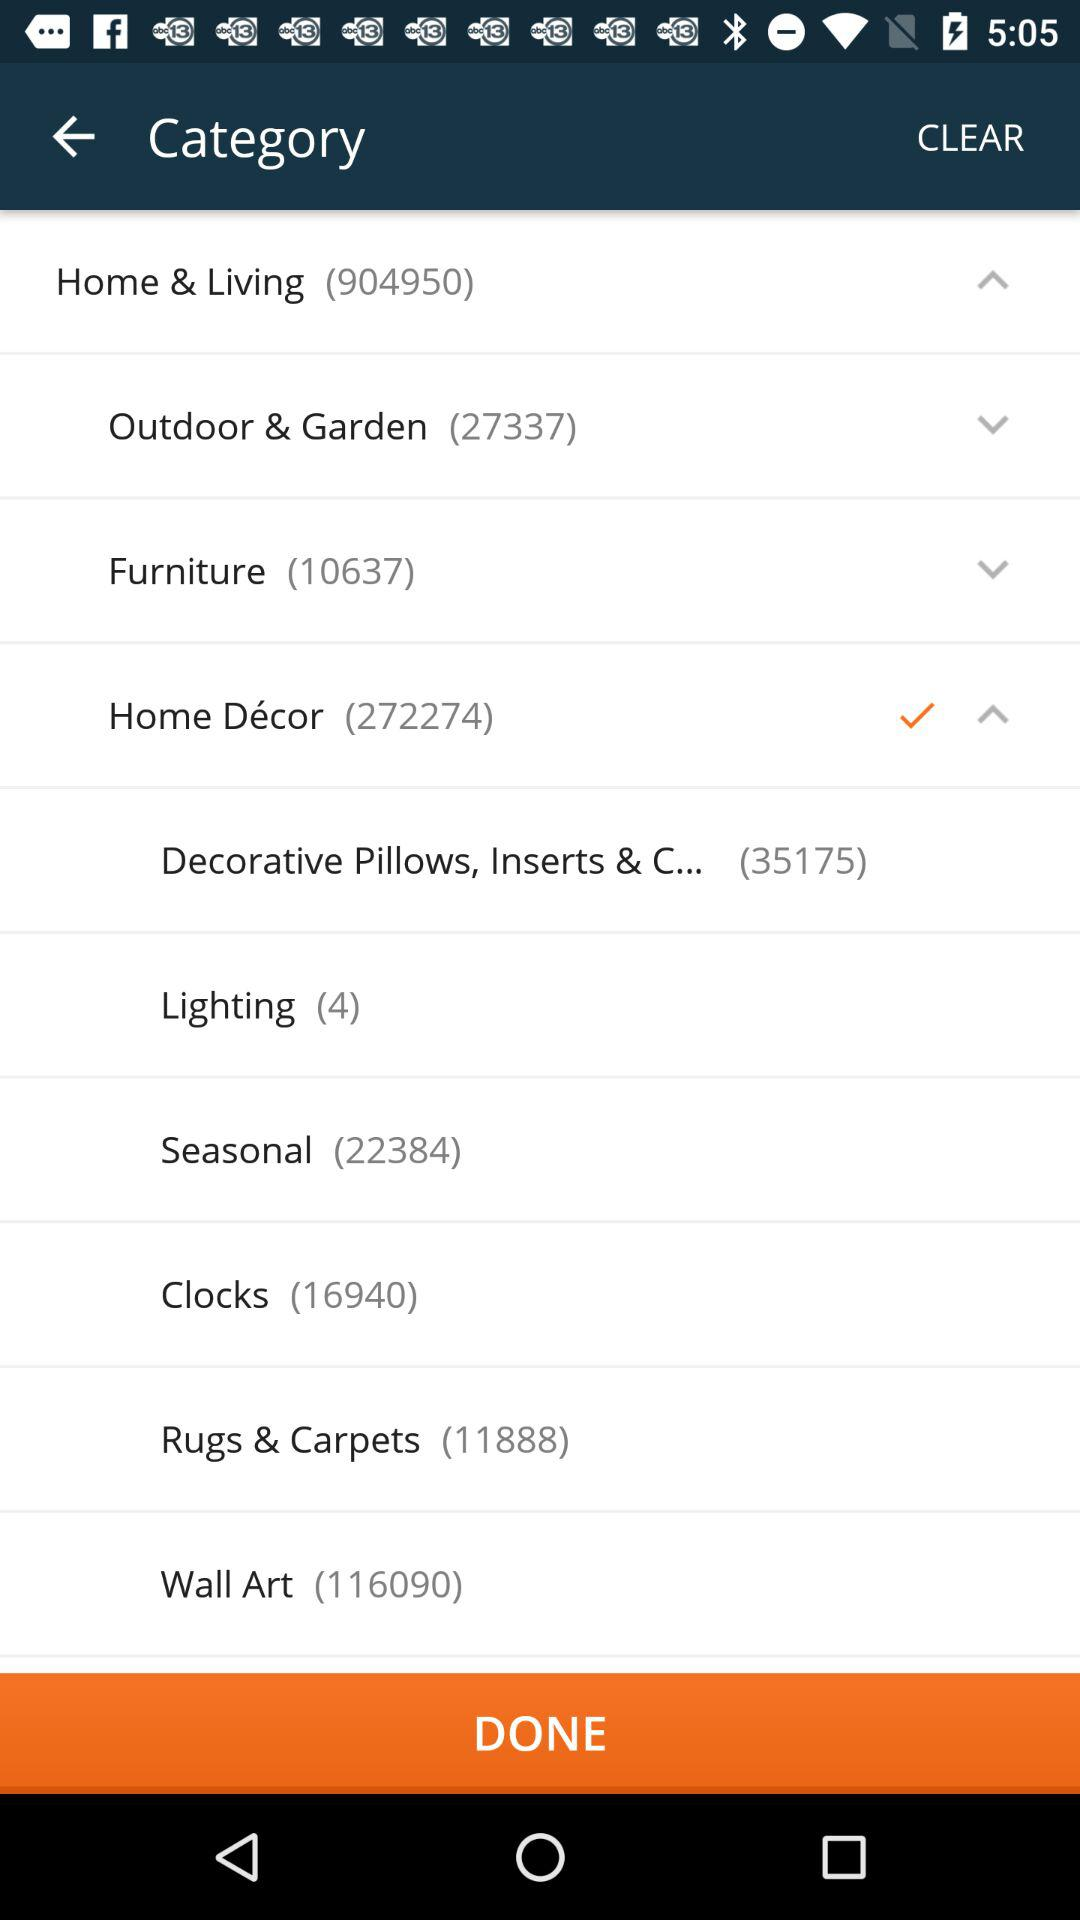What is the selected option? The selected option is "Home Décor". 